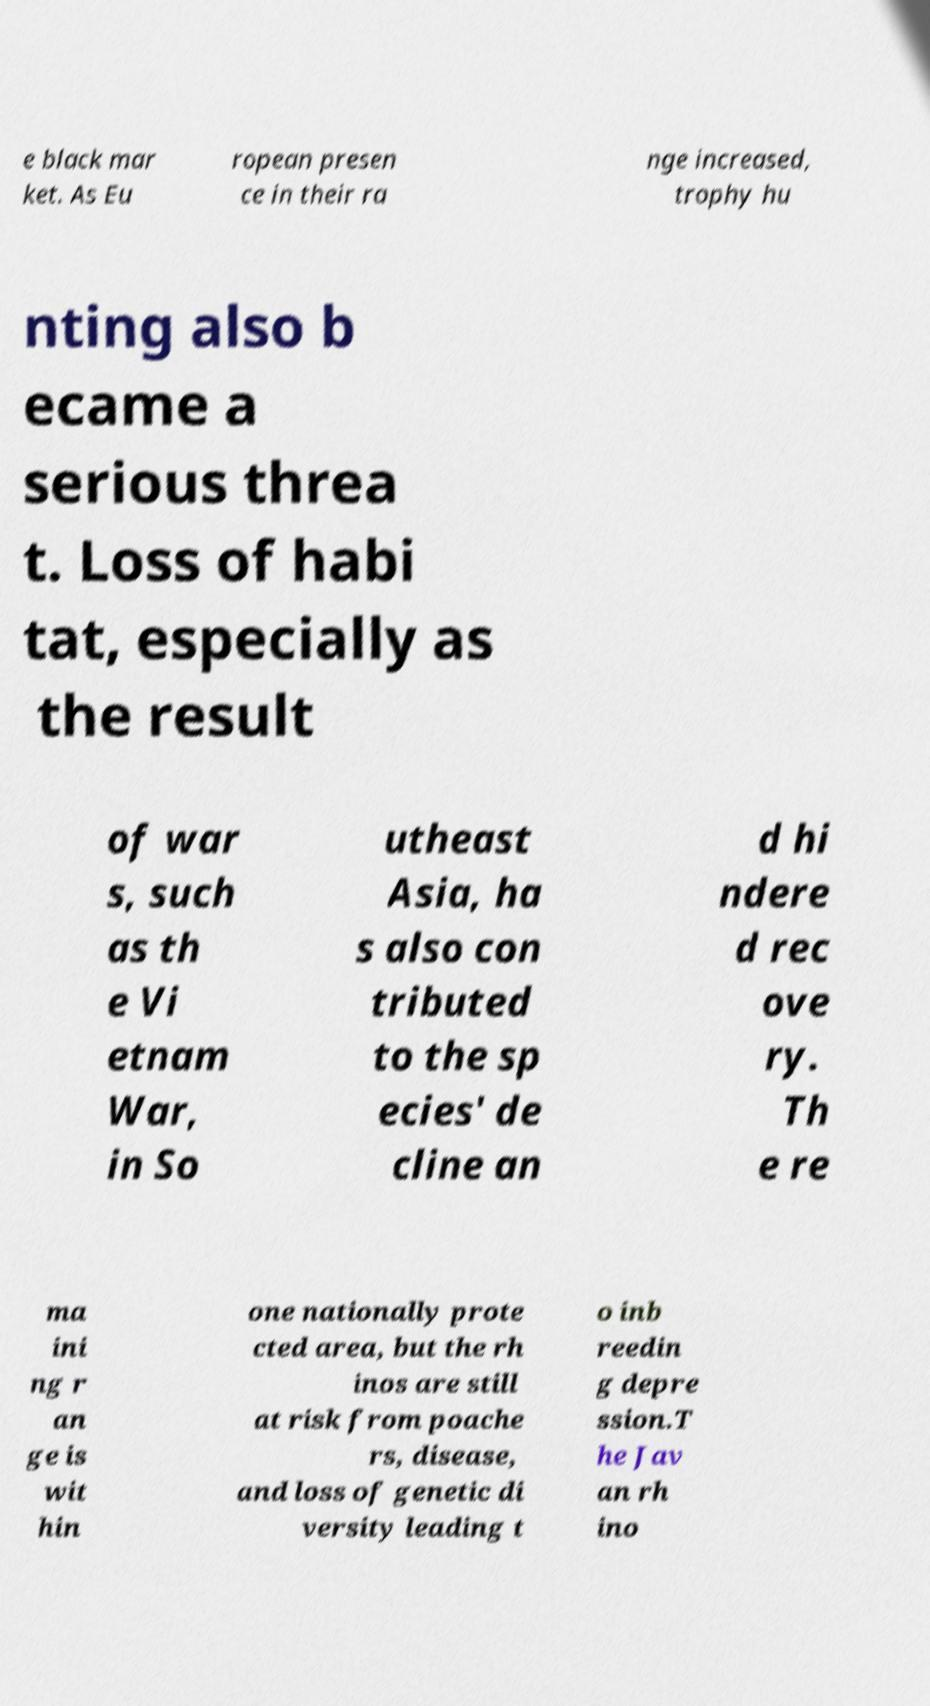Please identify and transcribe the text found in this image. e black mar ket. As Eu ropean presen ce in their ra nge increased, trophy hu nting also b ecame a serious threa t. Loss of habi tat, especially as the result of war s, such as th e Vi etnam War, in So utheast Asia, ha s also con tributed to the sp ecies' de cline an d hi ndere d rec ove ry. Th e re ma ini ng r an ge is wit hin one nationally prote cted area, but the rh inos are still at risk from poache rs, disease, and loss of genetic di versity leading t o inb reedin g depre ssion.T he Jav an rh ino 